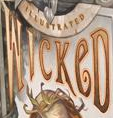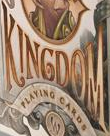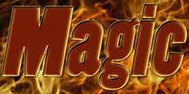Identify the words shown in these images in order, separated by a semicolon. WICKeD; KINGDOM; Magic 